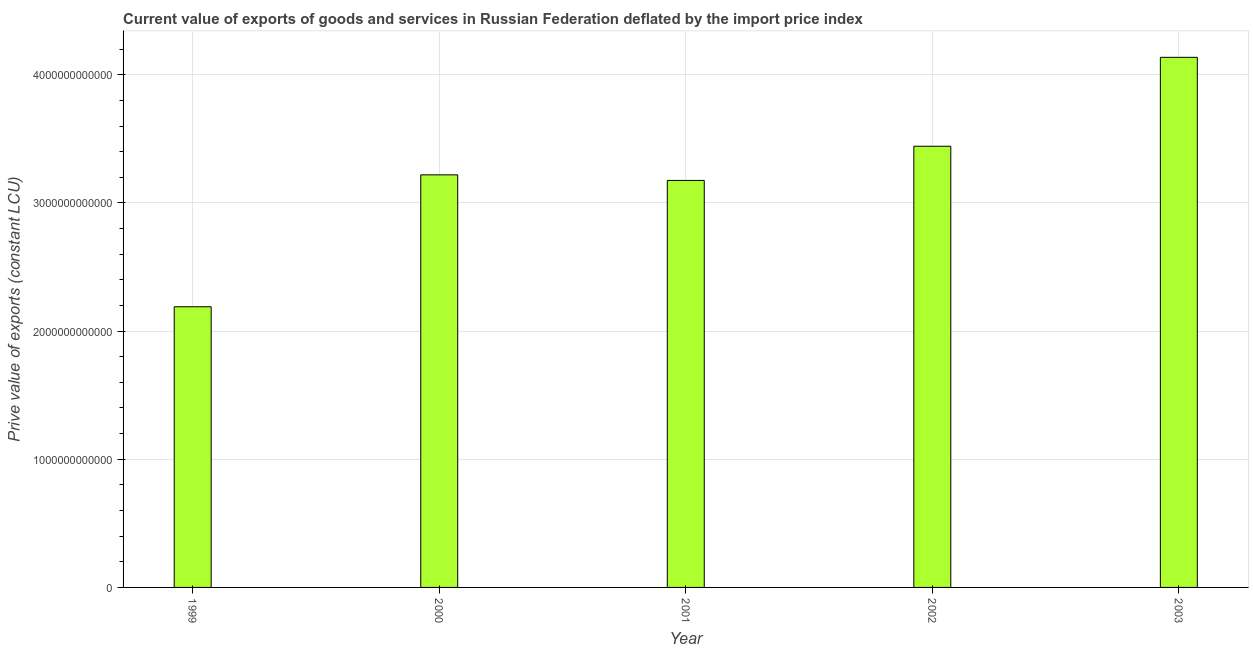Does the graph contain any zero values?
Your answer should be very brief. No. What is the title of the graph?
Your response must be concise. Current value of exports of goods and services in Russian Federation deflated by the import price index. What is the label or title of the X-axis?
Your answer should be compact. Year. What is the label or title of the Y-axis?
Give a very brief answer. Prive value of exports (constant LCU). What is the price value of exports in 1999?
Provide a succinct answer. 2.19e+12. Across all years, what is the maximum price value of exports?
Make the answer very short. 4.14e+12. Across all years, what is the minimum price value of exports?
Your answer should be compact. 2.19e+12. In which year was the price value of exports minimum?
Offer a very short reply. 1999. What is the sum of the price value of exports?
Your answer should be compact. 1.62e+13. What is the difference between the price value of exports in 1999 and 2003?
Your answer should be very brief. -1.95e+12. What is the average price value of exports per year?
Provide a succinct answer. 3.23e+12. What is the median price value of exports?
Provide a short and direct response. 3.22e+12. Do a majority of the years between 2003 and 2001 (inclusive) have price value of exports greater than 2400000000000 LCU?
Offer a very short reply. Yes. What is the ratio of the price value of exports in 2001 to that in 2003?
Your answer should be compact. 0.77. What is the difference between the highest and the second highest price value of exports?
Provide a short and direct response. 6.94e+11. What is the difference between the highest and the lowest price value of exports?
Give a very brief answer. 1.95e+12. In how many years, is the price value of exports greater than the average price value of exports taken over all years?
Offer a terse response. 2. How many bars are there?
Your answer should be very brief. 5. How many years are there in the graph?
Make the answer very short. 5. What is the difference between two consecutive major ticks on the Y-axis?
Provide a short and direct response. 1.00e+12. What is the Prive value of exports (constant LCU) of 1999?
Ensure brevity in your answer.  2.19e+12. What is the Prive value of exports (constant LCU) in 2000?
Keep it short and to the point. 3.22e+12. What is the Prive value of exports (constant LCU) of 2001?
Keep it short and to the point. 3.18e+12. What is the Prive value of exports (constant LCU) of 2002?
Provide a succinct answer. 3.44e+12. What is the Prive value of exports (constant LCU) in 2003?
Make the answer very short. 4.14e+12. What is the difference between the Prive value of exports (constant LCU) in 1999 and 2000?
Offer a very short reply. -1.03e+12. What is the difference between the Prive value of exports (constant LCU) in 1999 and 2001?
Your response must be concise. -9.86e+11. What is the difference between the Prive value of exports (constant LCU) in 1999 and 2002?
Your answer should be compact. -1.25e+12. What is the difference between the Prive value of exports (constant LCU) in 1999 and 2003?
Your answer should be compact. -1.95e+12. What is the difference between the Prive value of exports (constant LCU) in 2000 and 2001?
Offer a very short reply. 4.35e+1. What is the difference between the Prive value of exports (constant LCU) in 2000 and 2002?
Provide a short and direct response. -2.23e+11. What is the difference between the Prive value of exports (constant LCU) in 2000 and 2003?
Give a very brief answer. -9.17e+11. What is the difference between the Prive value of exports (constant LCU) in 2001 and 2002?
Ensure brevity in your answer.  -2.67e+11. What is the difference between the Prive value of exports (constant LCU) in 2001 and 2003?
Your response must be concise. -9.60e+11. What is the difference between the Prive value of exports (constant LCU) in 2002 and 2003?
Make the answer very short. -6.94e+11. What is the ratio of the Prive value of exports (constant LCU) in 1999 to that in 2000?
Your answer should be very brief. 0.68. What is the ratio of the Prive value of exports (constant LCU) in 1999 to that in 2001?
Make the answer very short. 0.69. What is the ratio of the Prive value of exports (constant LCU) in 1999 to that in 2002?
Make the answer very short. 0.64. What is the ratio of the Prive value of exports (constant LCU) in 1999 to that in 2003?
Keep it short and to the point. 0.53. What is the ratio of the Prive value of exports (constant LCU) in 2000 to that in 2001?
Keep it short and to the point. 1.01. What is the ratio of the Prive value of exports (constant LCU) in 2000 to that in 2002?
Offer a terse response. 0.94. What is the ratio of the Prive value of exports (constant LCU) in 2000 to that in 2003?
Your response must be concise. 0.78. What is the ratio of the Prive value of exports (constant LCU) in 2001 to that in 2002?
Provide a succinct answer. 0.92. What is the ratio of the Prive value of exports (constant LCU) in 2001 to that in 2003?
Give a very brief answer. 0.77. What is the ratio of the Prive value of exports (constant LCU) in 2002 to that in 2003?
Ensure brevity in your answer.  0.83. 